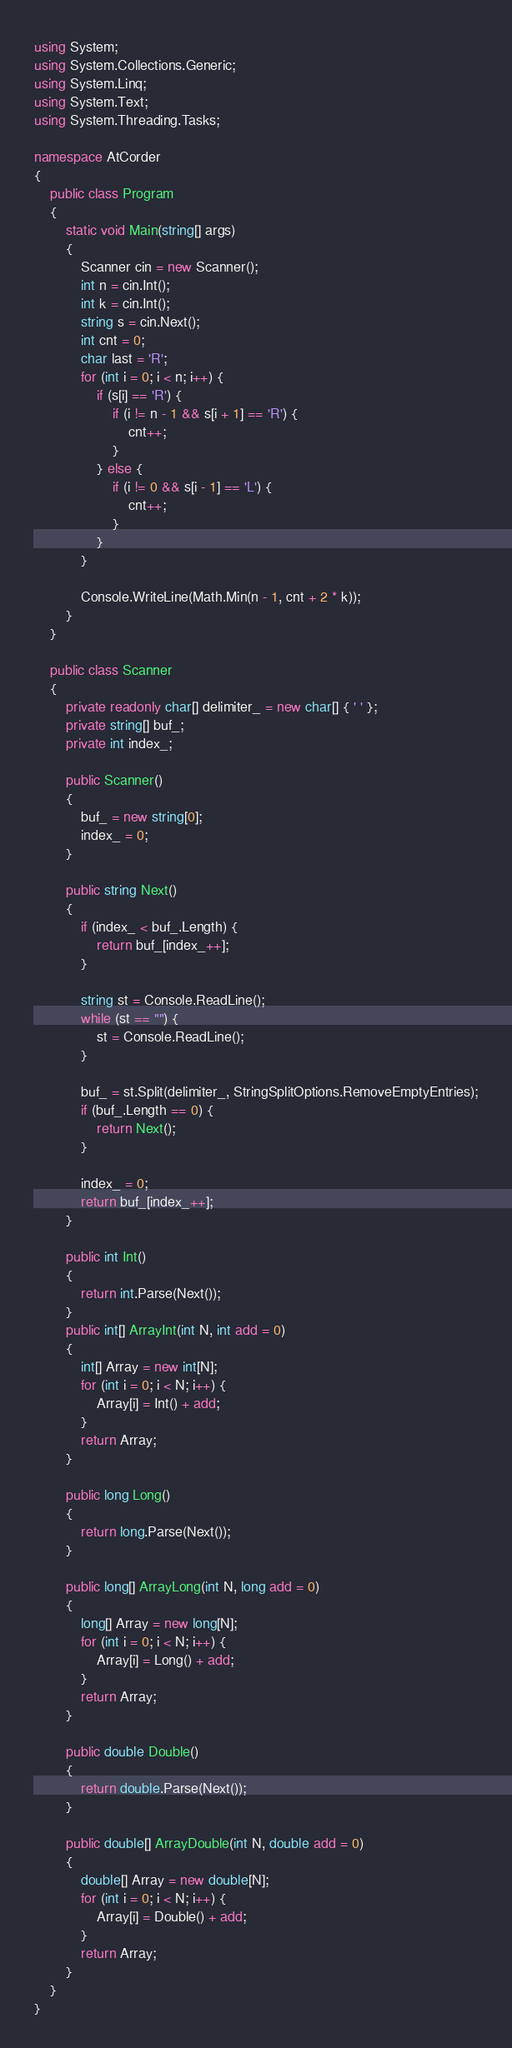Convert code to text. <code><loc_0><loc_0><loc_500><loc_500><_C#_>using System;
using System.Collections.Generic;
using System.Linq;
using System.Text;
using System.Threading.Tasks;

namespace AtCorder
{
	public class Program
	{
		static void Main(string[] args)
		{
			Scanner cin = new Scanner();
			int n = cin.Int();
			int k = cin.Int();
			string s = cin.Next();
			int cnt = 0;
			char last = 'R';
			for (int i = 0; i < n; i++) {
				if (s[i] == 'R') {
					if (i != n - 1 && s[i + 1] == 'R') {
						cnt++;
					}
				} else {
					if (i != 0 && s[i - 1] == 'L') {
						cnt++;
					}
				}
			}

			Console.WriteLine(Math.Min(n - 1, cnt + 2 * k));
		}
	}

	public class Scanner
	{
		private readonly char[] delimiter_ = new char[] { ' ' };
		private string[] buf_;
		private int index_;

		public Scanner()
		{
			buf_ = new string[0];
			index_ = 0;
		}

		public string Next()
		{
			if (index_ < buf_.Length) {
				return buf_[index_++];
			}

			string st = Console.ReadLine();
			while (st == "") {
				st = Console.ReadLine();
			}

			buf_ = st.Split(delimiter_, StringSplitOptions.RemoveEmptyEntries);
			if (buf_.Length == 0) {
				return Next();
			}

			index_ = 0;
			return buf_[index_++];
		}

		public int Int()
		{
			return int.Parse(Next());
		}
		public int[] ArrayInt(int N, int add = 0)
		{
			int[] Array = new int[N];
			for (int i = 0; i < N; i++) {
				Array[i] = Int() + add;
			}
			return Array;
		}

		public long Long()
		{
			return long.Parse(Next());
		}

		public long[] ArrayLong(int N, long add = 0)
		{
			long[] Array = new long[N];
			for (int i = 0; i < N; i++) {
				Array[i] = Long() + add;
			}
			return Array;
		}

		public double Double()
		{
			return double.Parse(Next());
		}

		public double[] ArrayDouble(int N, double add = 0)
		{
			double[] Array = new double[N];
			for (int i = 0; i < N; i++) {
				Array[i] = Double() + add;
			}
			return Array;
		}
	}
}</code> 